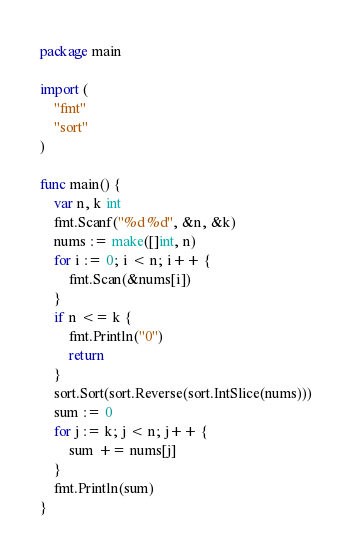Convert code to text. <code><loc_0><loc_0><loc_500><loc_500><_Go_>package main

import (
	"fmt"
	"sort"
)

func main() {
	var n, k int
	fmt.Scanf("%d %d", &n, &k)
	nums := make([]int, n)
	for i := 0; i < n; i++ {
		fmt.Scan(&nums[i])
	}
	if n <= k {
		fmt.Println("0")
		return
	}
	sort.Sort(sort.Reverse(sort.IntSlice(nums)))
	sum := 0
	for j := k; j < n; j++ {
		sum += nums[j]
	}
	fmt.Println(sum)
}
</code> 